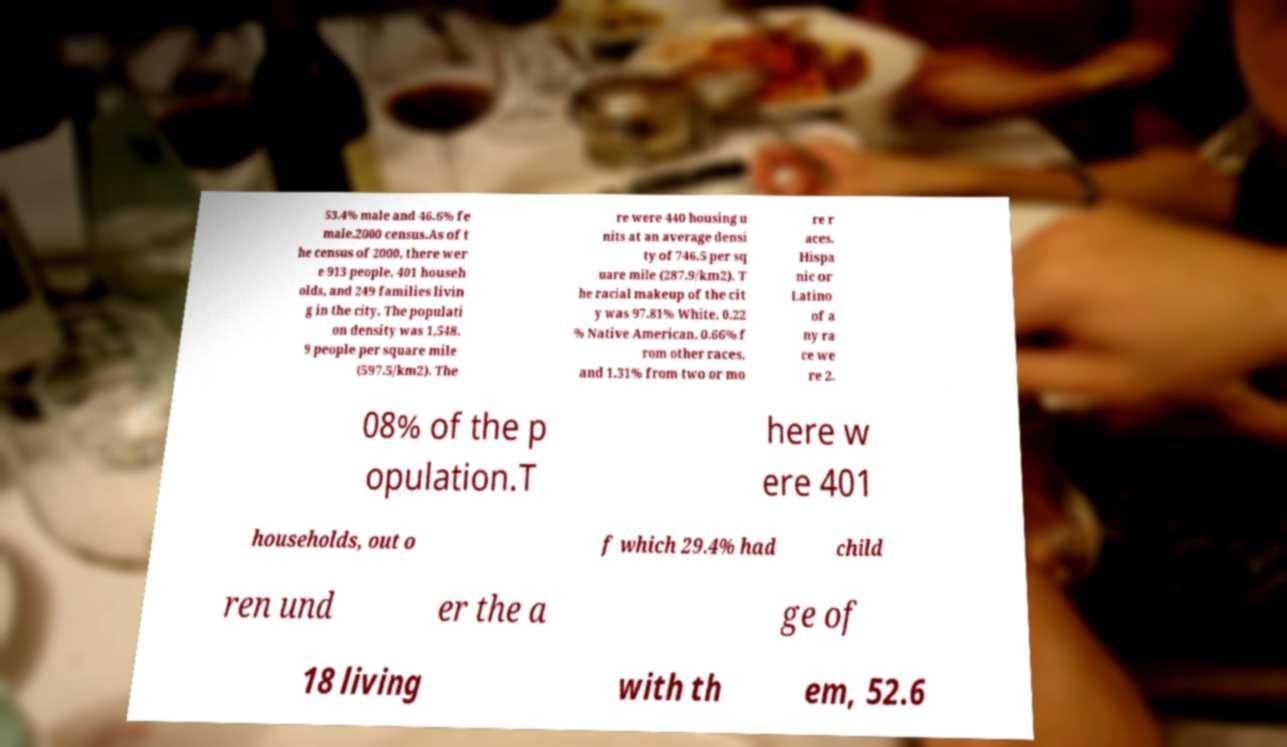Please identify and transcribe the text found in this image. 53.4% male and 46.6% fe male.2000 census.As of t he census of 2000, there wer e 913 people, 401 househ olds, and 249 families livin g in the city. The populati on density was 1,548. 9 people per square mile (597.5/km2). The re were 440 housing u nits at an average densi ty of 746.5 per sq uare mile (287.9/km2). T he racial makeup of the cit y was 97.81% White, 0.22 % Native American, 0.66% f rom other races, and 1.31% from two or mo re r aces. Hispa nic or Latino of a ny ra ce we re 2. 08% of the p opulation.T here w ere 401 households, out o f which 29.4% had child ren und er the a ge of 18 living with th em, 52.6 